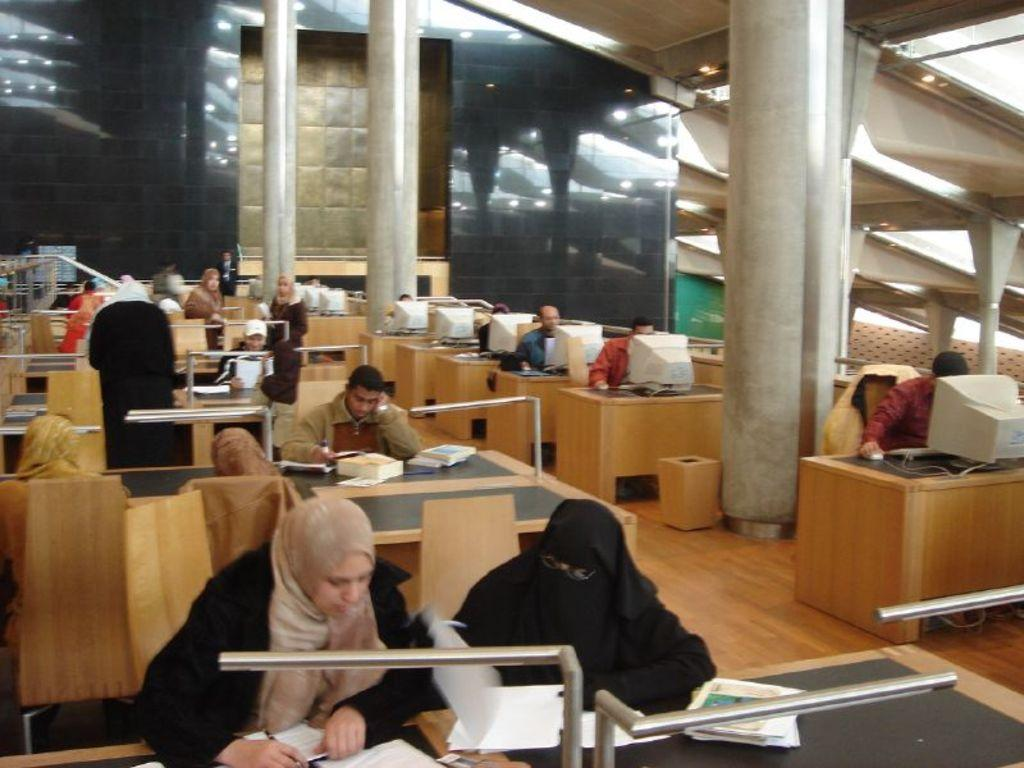What type of environment is shown in the image? The image depicts an office setting. What are the people in the image doing? Some people are working on systems, while others are working on paper. What positions are the people in the image adopting? Some people are standing, while others are sitting. What type of arithmetic problem is being solved on the whiteboard in the image? There is no whiteboard or arithmetic problem present in the image. What government agency is responsible for the office depicted in the image? The image does not provide any information about the government agency associated with the office. 